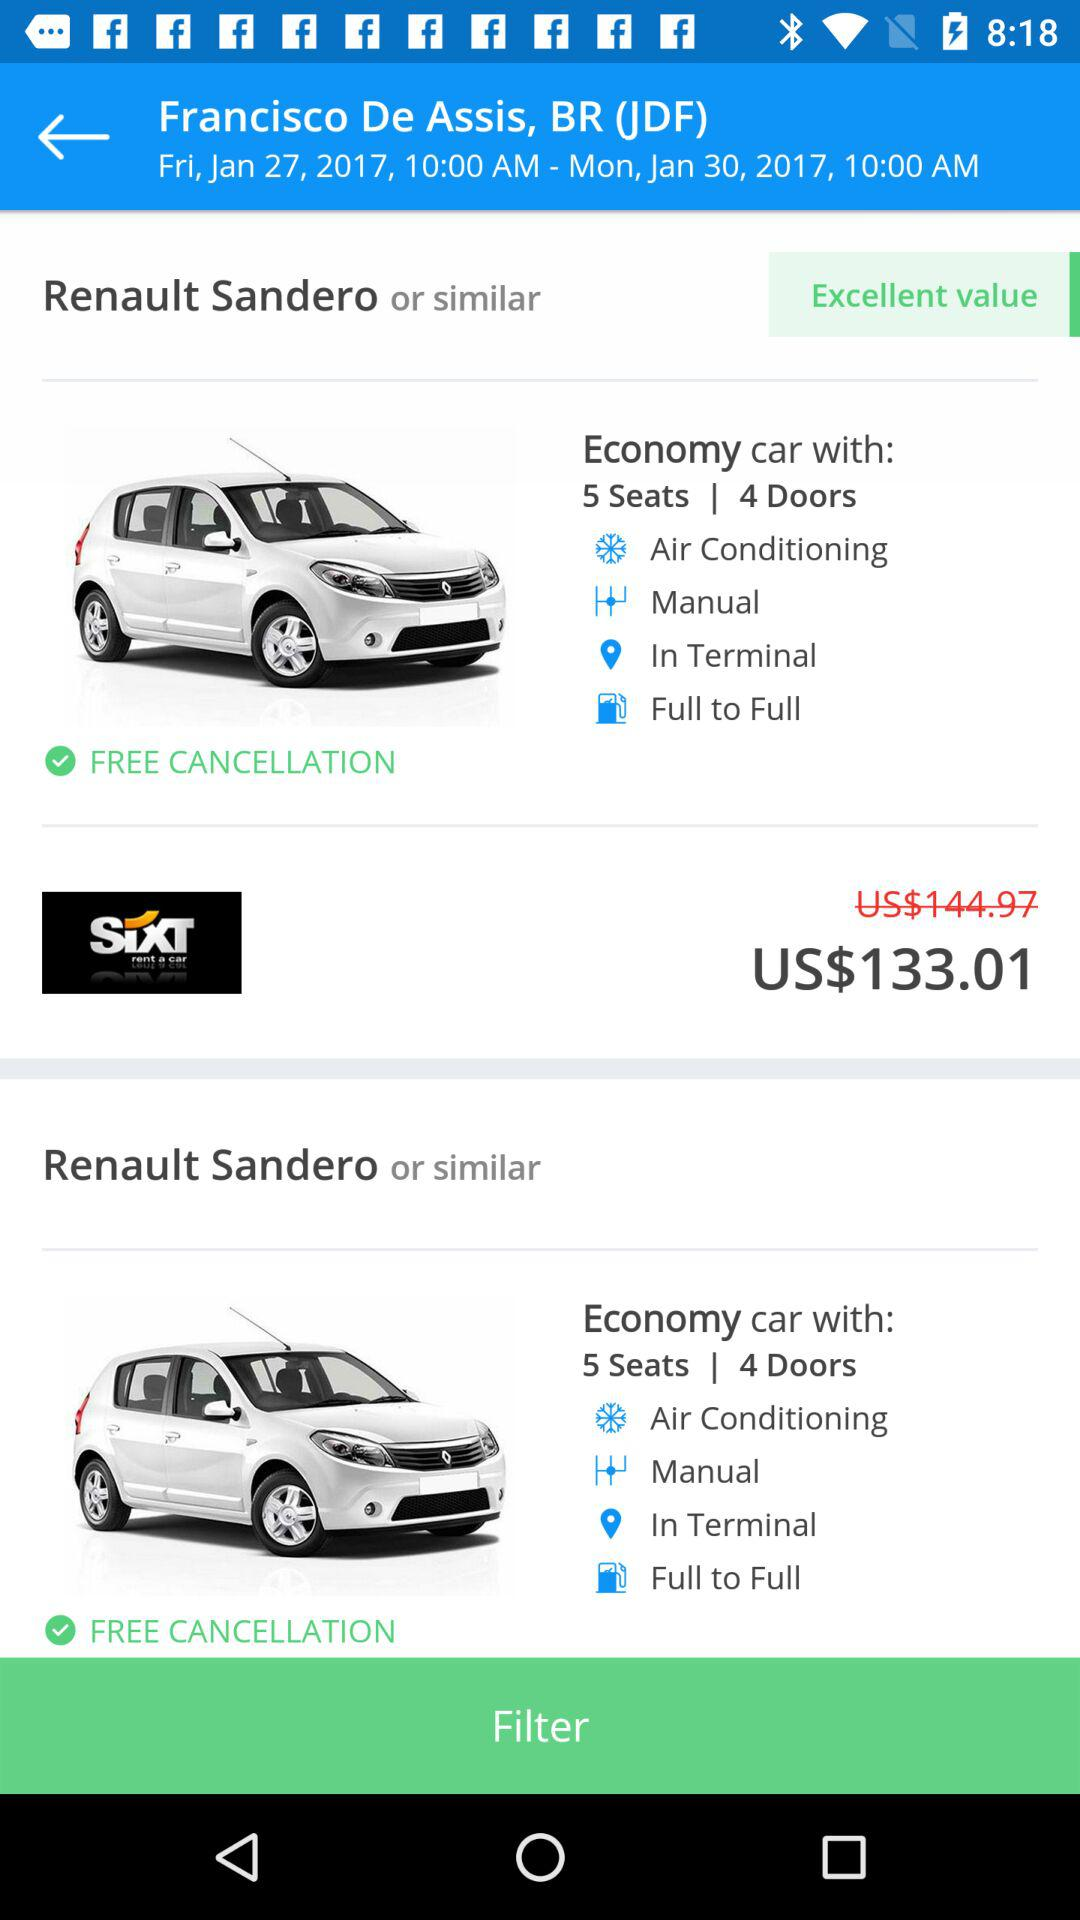What is the location? The location is Juiz de Fora, Brazil. 